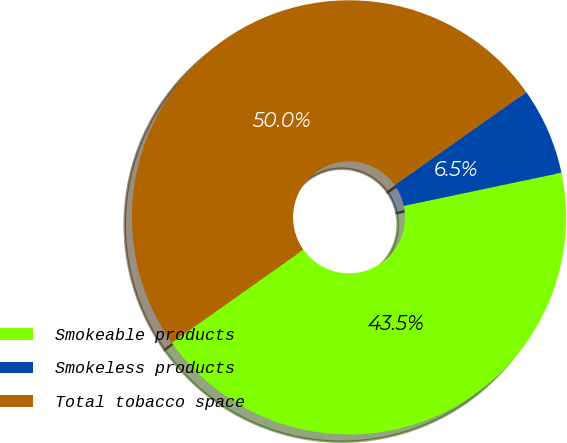<chart> <loc_0><loc_0><loc_500><loc_500><pie_chart><fcel>Smokeable products<fcel>Smokeless products<fcel>Total tobacco space<nl><fcel>43.51%<fcel>6.49%<fcel>50.0%<nl></chart> 